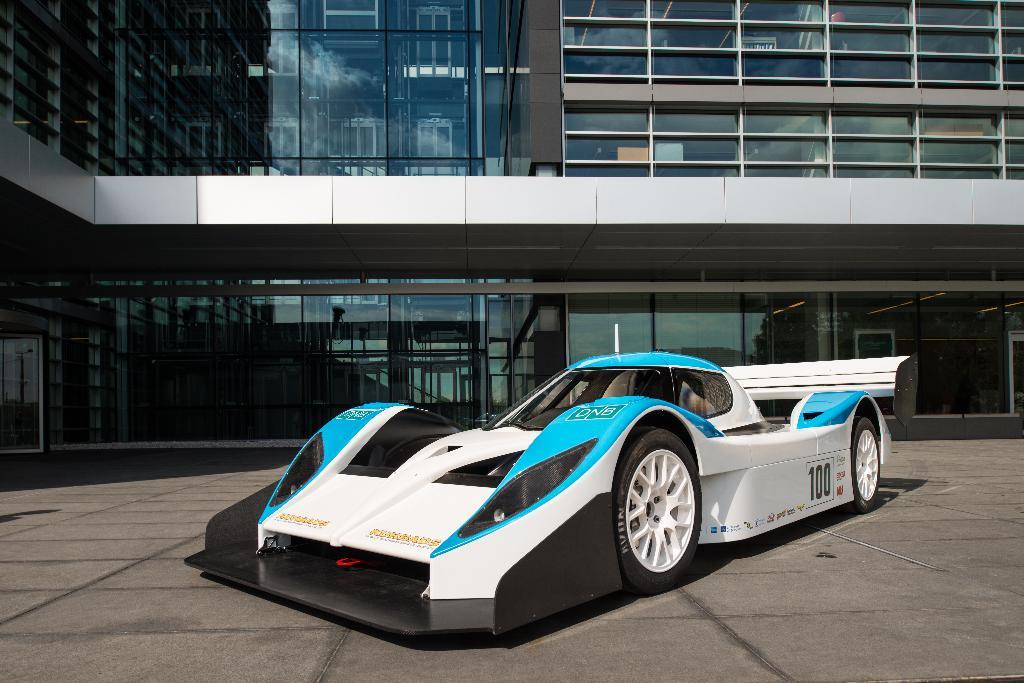What is the main subject in the center of the image? There is a car in the center of the image. What can be seen in the background of the image? There is a skyscraper in the background of the image. What type of noise can be heard coming from the oven in the image? There is no oven present in the image, so it is not possible to determine what, if any, noise might be heard. 